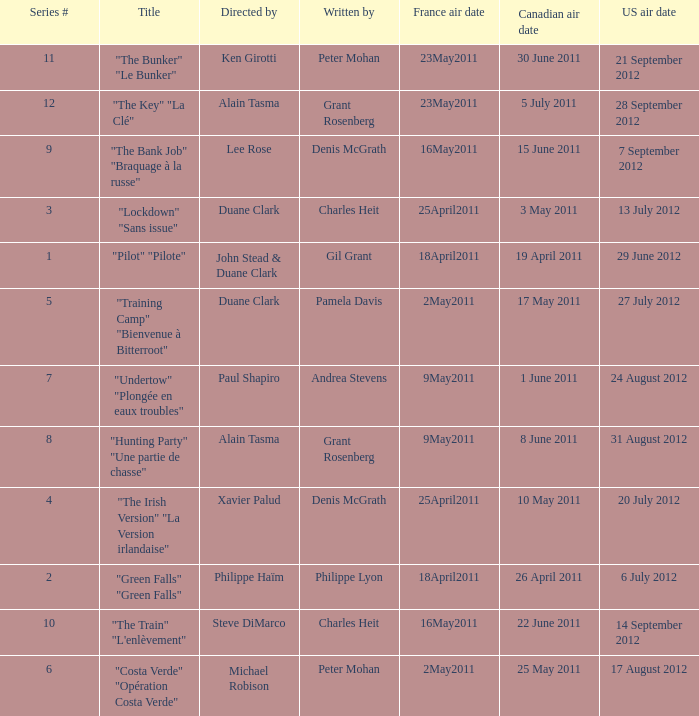What is the series # when the US air date is 20 July 2012? 4.0. 